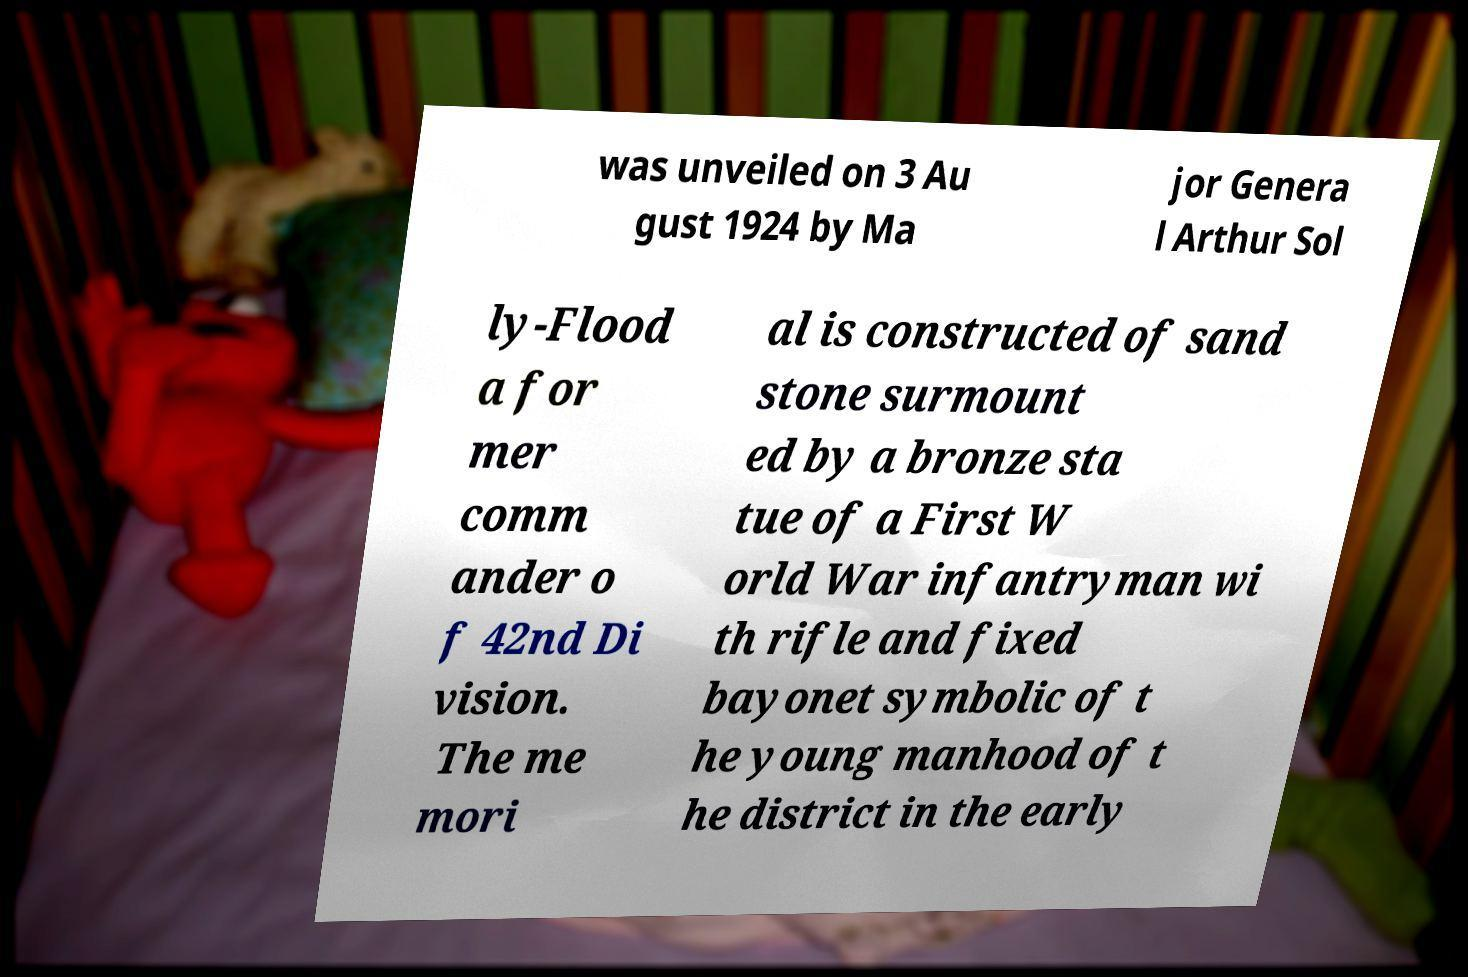There's text embedded in this image that I need extracted. Can you transcribe it verbatim? was unveiled on 3 Au gust 1924 by Ma jor Genera l Arthur Sol ly-Flood a for mer comm ander o f 42nd Di vision. The me mori al is constructed of sand stone surmount ed by a bronze sta tue of a First W orld War infantryman wi th rifle and fixed bayonet symbolic of t he young manhood of t he district in the early 